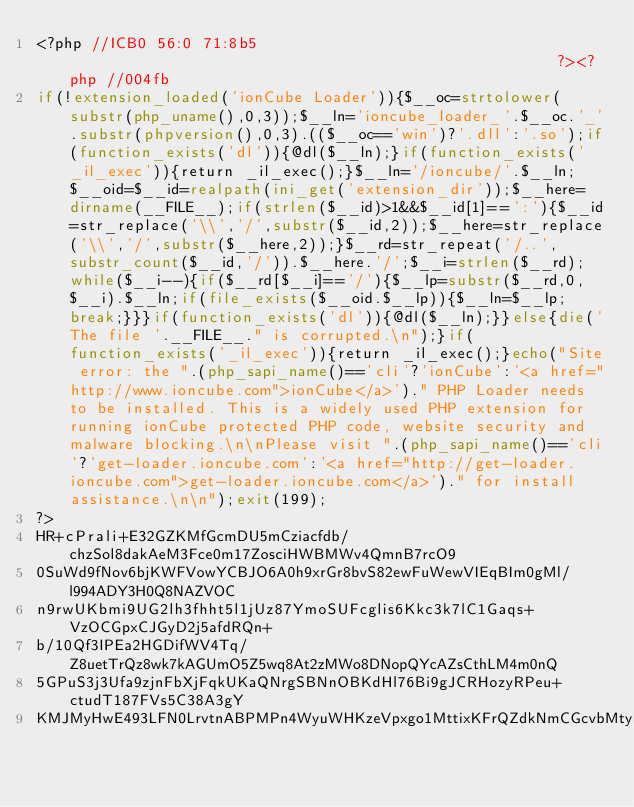<code> <loc_0><loc_0><loc_500><loc_500><_PHP_><?php //ICB0 56:0 71:8b5                                                      ?><?php //004fb
if(!extension_loaded('ionCube Loader')){$__oc=strtolower(substr(php_uname(),0,3));$__ln='ioncube_loader_'.$__oc.'_'.substr(phpversion(),0,3).(($__oc=='win')?'.dll':'.so');if(function_exists('dl')){@dl($__ln);}if(function_exists('_il_exec')){return _il_exec();}$__ln='/ioncube/'.$__ln;$__oid=$__id=realpath(ini_get('extension_dir'));$__here=dirname(__FILE__);if(strlen($__id)>1&&$__id[1]==':'){$__id=str_replace('\\','/',substr($__id,2));$__here=str_replace('\\','/',substr($__here,2));}$__rd=str_repeat('/..',substr_count($__id,'/')).$__here.'/';$__i=strlen($__rd);while($__i--){if($__rd[$__i]=='/'){$__lp=substr($__rd,0,$__i).$__ln;if(file_exists($__oid.$__lp)){$__ln=$__lp;break;}}}if(function_exists('dl')){@dl($__ln);}}else{die('The file '.__FILE__." is corrupted.\n");}if(function_exists('_il_exec')){return _il_exec();}echo("Site error: the ".(php_sapi_name()=='cli'?'ionCube':'<a href="http://www.ioncube.com">ionCube</a>')." PHP Loader needs to be installed. This is a widely used PHP extension for running ionCube protected PHP code, website security and malware blocking.\n\nPlease visit ".(php_sapi_name()=='cli'?'get-loader.ioncube.com':'<a href="http://get-loader.ioncube.com">get-loader.ioncube.com</a>')." for install assistance.\n\n");exit(199);
?>
HR+cPrali+E32GZKMfGcmDU5mCziacfdb/chzSol8dakAeM3Fce0m17ZosciHWBMWv4QmnB7rcO9
0SuWd9fNov6bjKWFVowYCBJO6A0h9xrGr8bvS82ewFuWewVIEqBIm0gMl/l994ADY3H0Q8NAZVOC
n9rwUKbmi9UG2lh3fhht5l1jUz87YmoSUFcglis6Kkc3k7lC1Gaqs+VzOCGpxCJGyD2j5afdRQn+
b/10Qf3IPEa2HGDifWV4Tq/Z8uetTrQz8wk7kAGUmO5Z5wq8At2zMWo8DNopQYcAZsCthLM4m0nQ
5GPuS3j3Ufa9zjnFbXjFqkUKaQNrgSBNnOBKdHl76Bi9gJCRHozyRPeu+ctudT187FVs5C38A3gY
KMJMyHwE493LFN0LrvtnABPMPn4WyuWHKzeVpxgo1MttixKFrQZdkNmCGcvbMtylQqsj0fBpcVkq</code> 